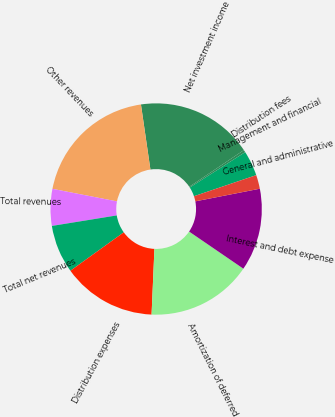Convert chart. <chart><loc_0><loc_0><loc_500><loc_500><pie_chart><fcel>Management and financial<fcel>Distribution fees<fcel>Net investment income<fcel>Other revenues<fcel>Total revenues<fcel>Total net revenues<fcel>Distribution expenses<fcel>Amortization of deferred<fcel>Interest and debt expense<fcel>General and administrative<nl><fcel>3.86%<fcel>0.36%<fcel>17.89%<fcel>19.64%<fcel>5.62%<fcel>7.37%<fcel>14.38%<fcel>16.14%<fcel>12.63%<fcel>2.11%<nl></chart> 